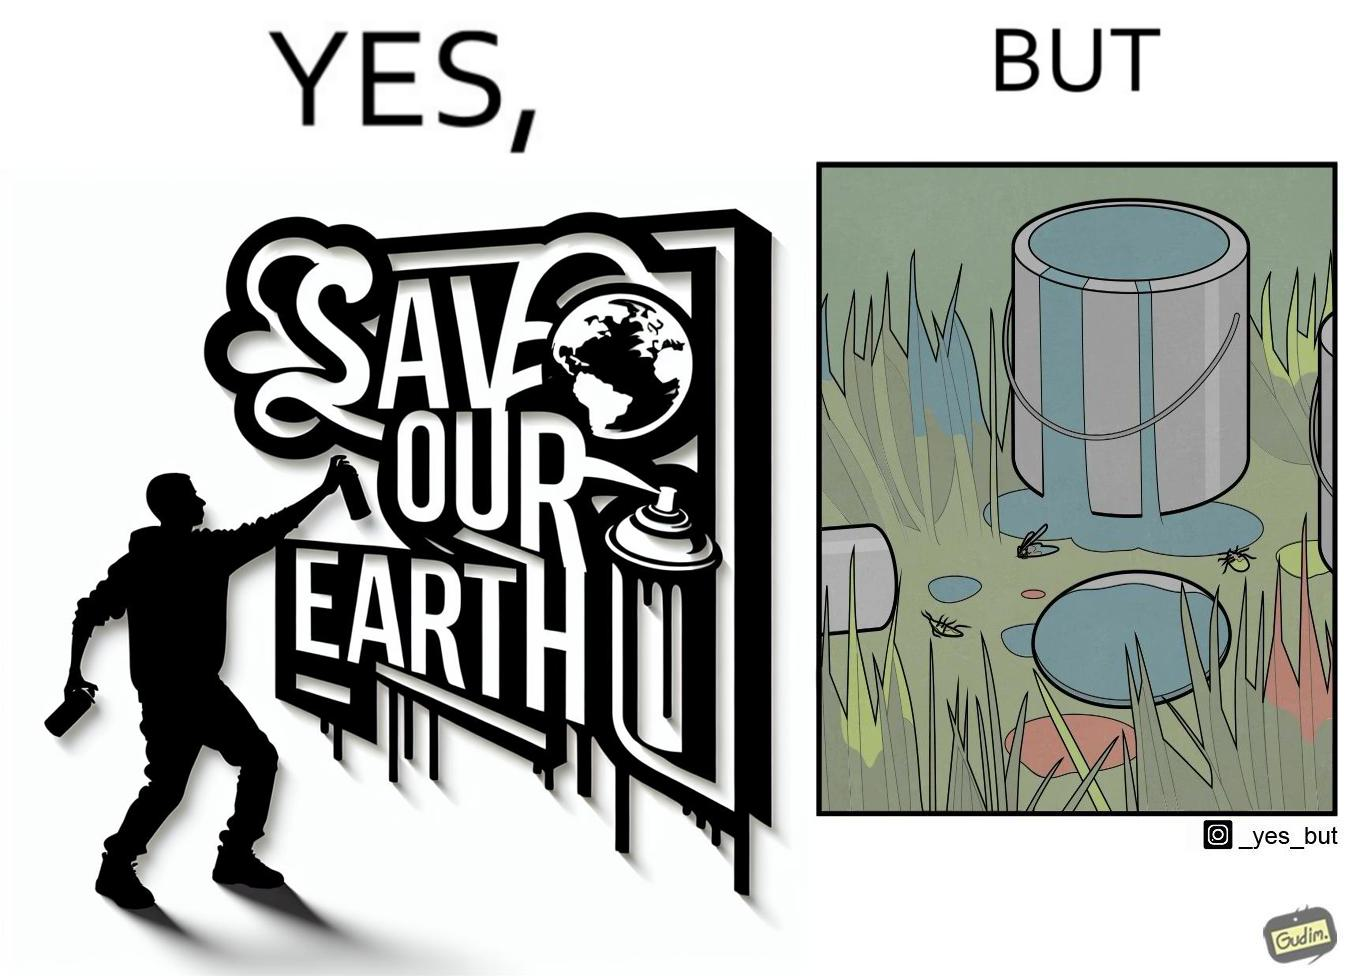Does this image contain satire or humor? Yes, this image is satirical. 